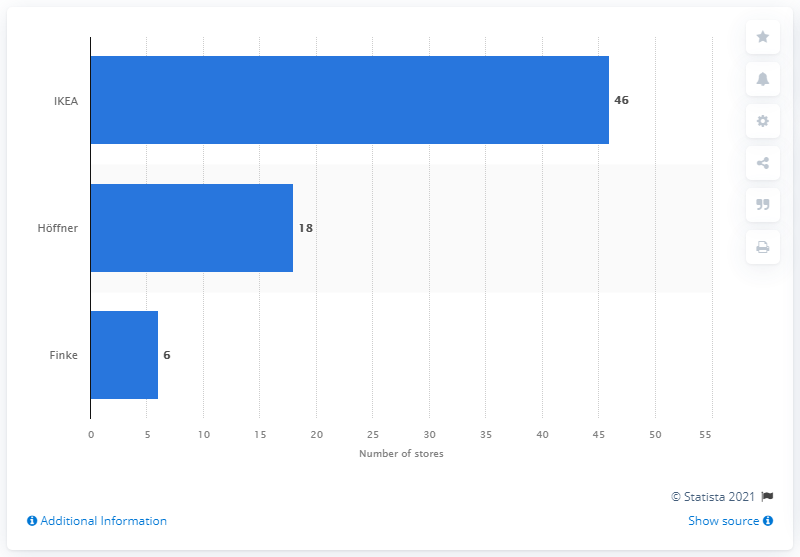Point out several critical features in this image. In 2013, there were 18 H&Fner stores located in Germany. IKEA had 46 stores in Germany in 2013. 